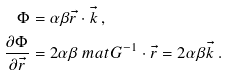<formula> <loc_0><loc_0><loc_500><loc_500>\Phi & = \alpha \beta \vec { r } \cdot \vec { k } \, , \\ \frac { \partial \Phi } { \partial \vec { r } } & = 2 \alpha \beta \ m a t { G } ^ { - 1 } \cdot \vec { r } = 2 \alpha \beta \vec { k } \, .</formula> 